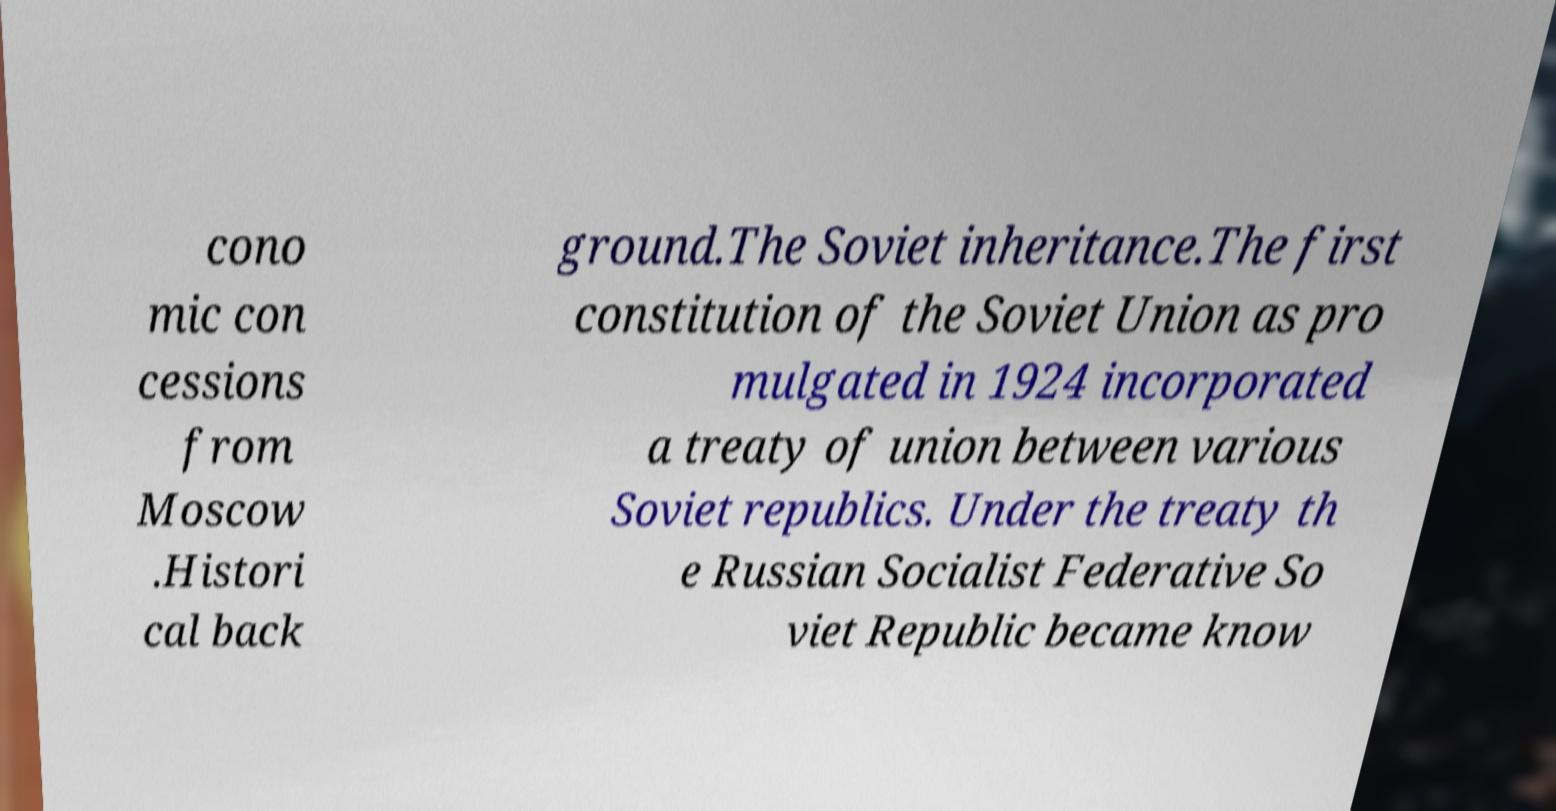Could you assist in decoding the text presented in this image and type it out clearly? cono mic con cessions from Moscow .Histori cal back ground.The Soviet inheritance.The first constitution of the Soviet Union as pro mulgated in 1924 incorporated a treaty of union between various Soviet republics. Under the treaty th e Russian Socialist Federative So viet Republic became know 